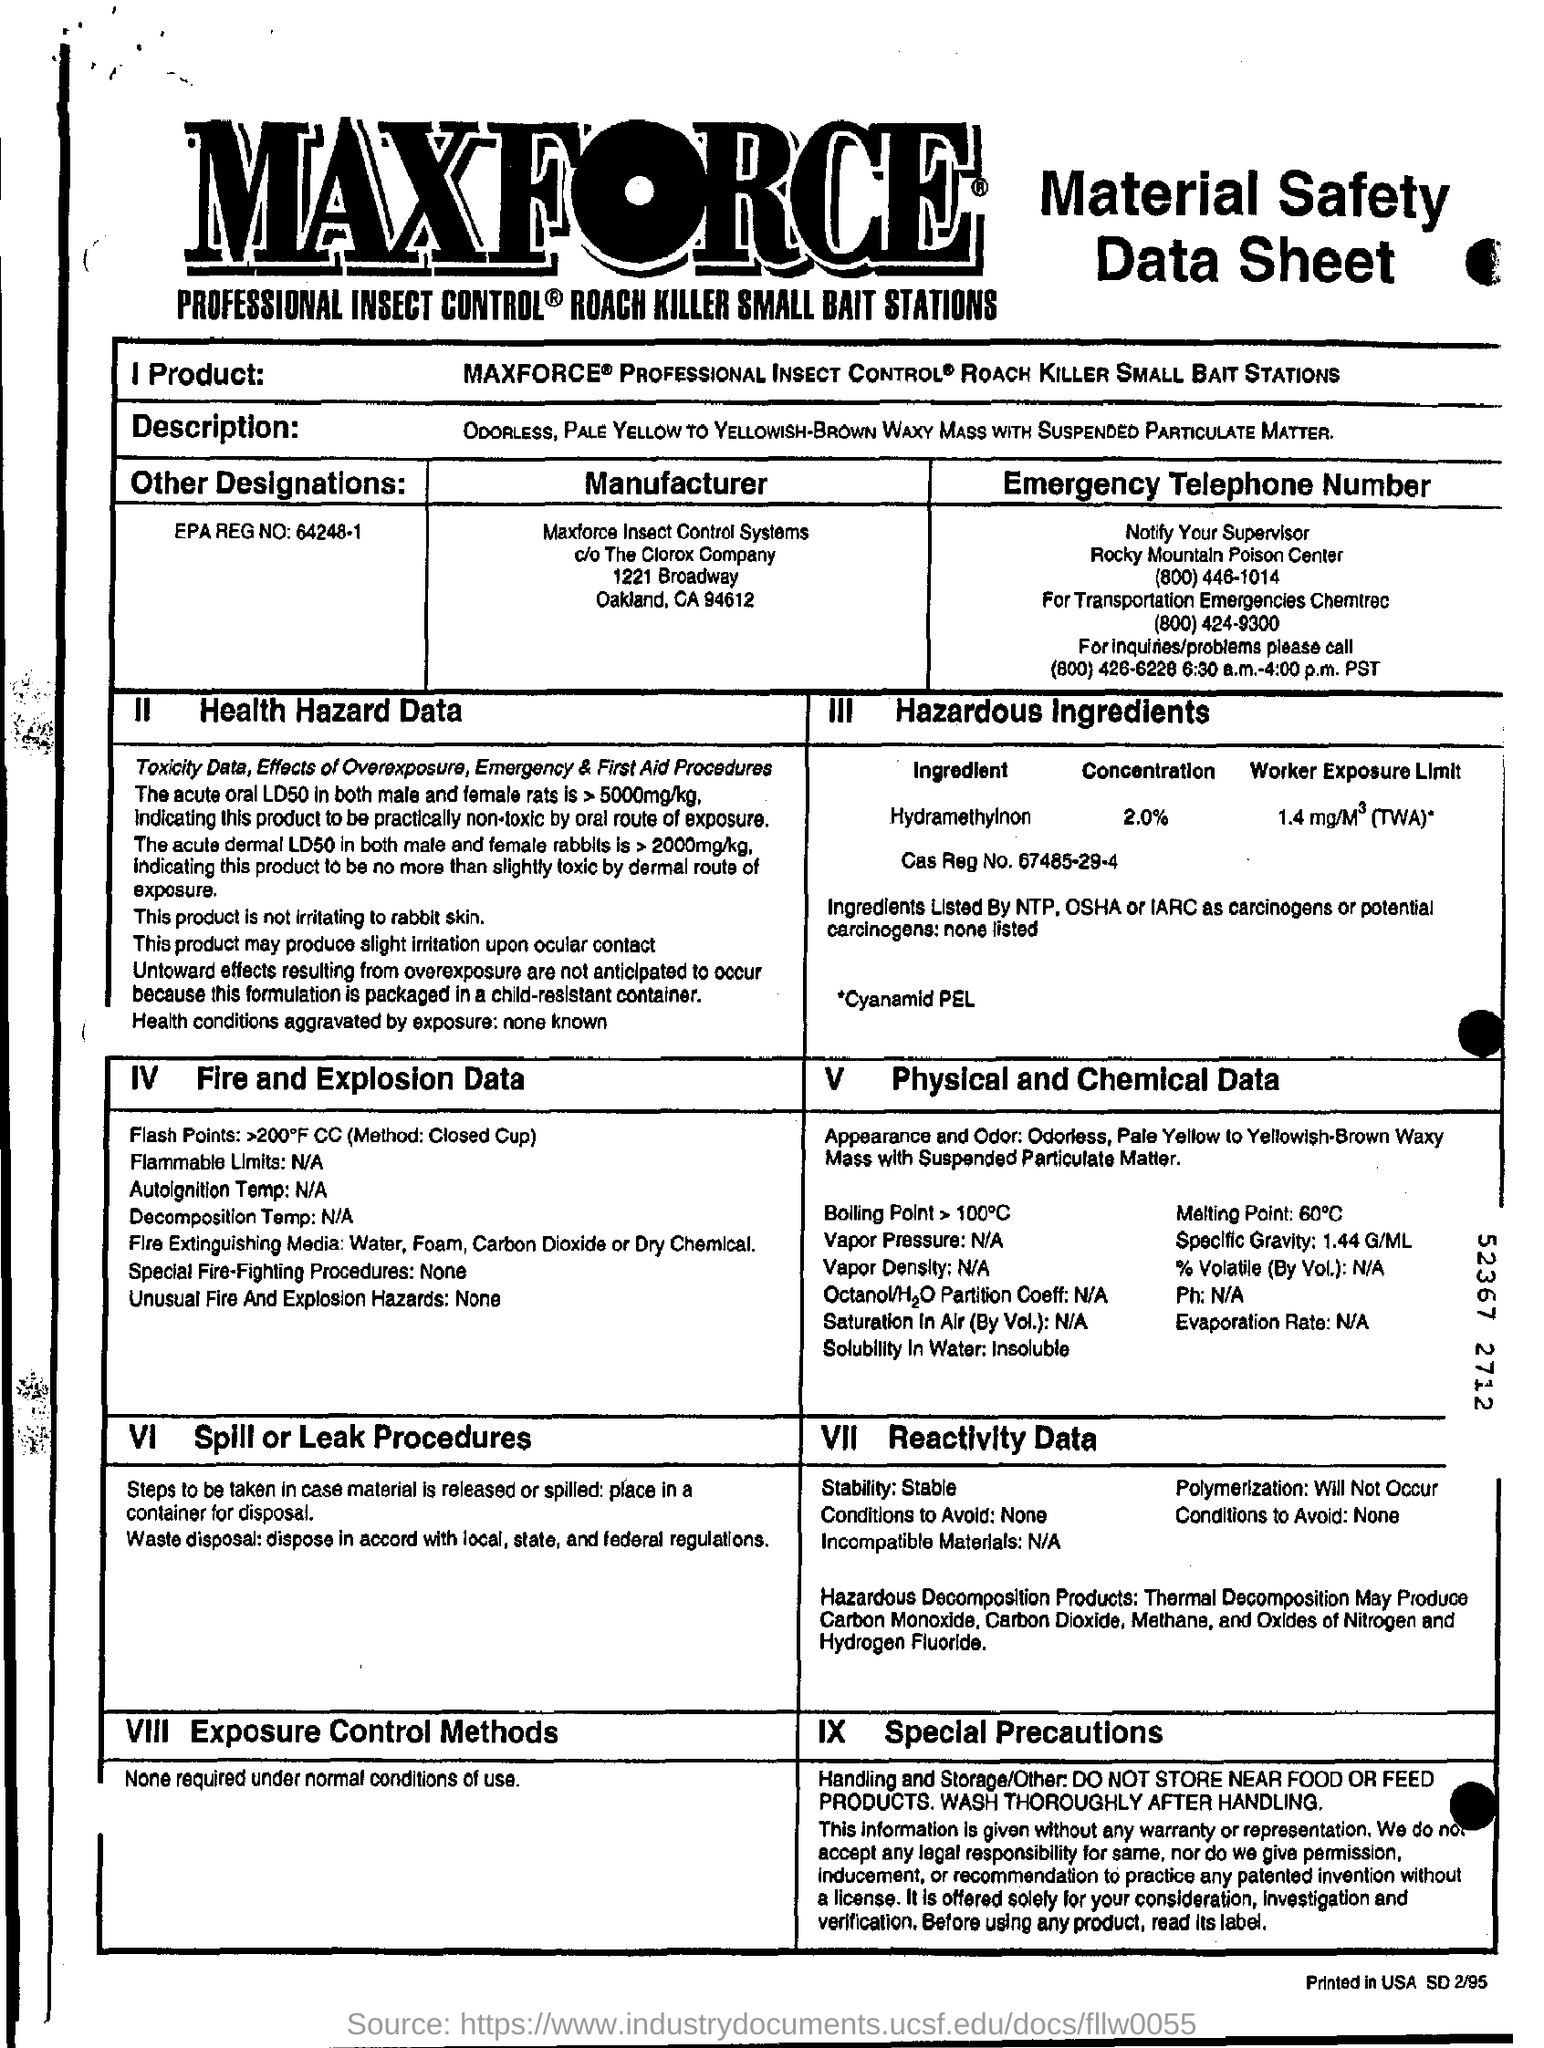What is the EPA REG NO?
Ensure brevity in your answer.  64248-1. Who is the manufacturer?
Make the answer very short. MAXFORCE INSECT CONTROL SYSTEMS. What is the concentration limit of Hydramethylnon?
Your answer should be compact. 2.0%. What is the Cas Reg No.?
Provide a short and direct response. 67485-29-4. 